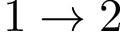<formula> <loc_0><loc_0><loc_500><loc_500>1 \rightarrow 2</formula> 